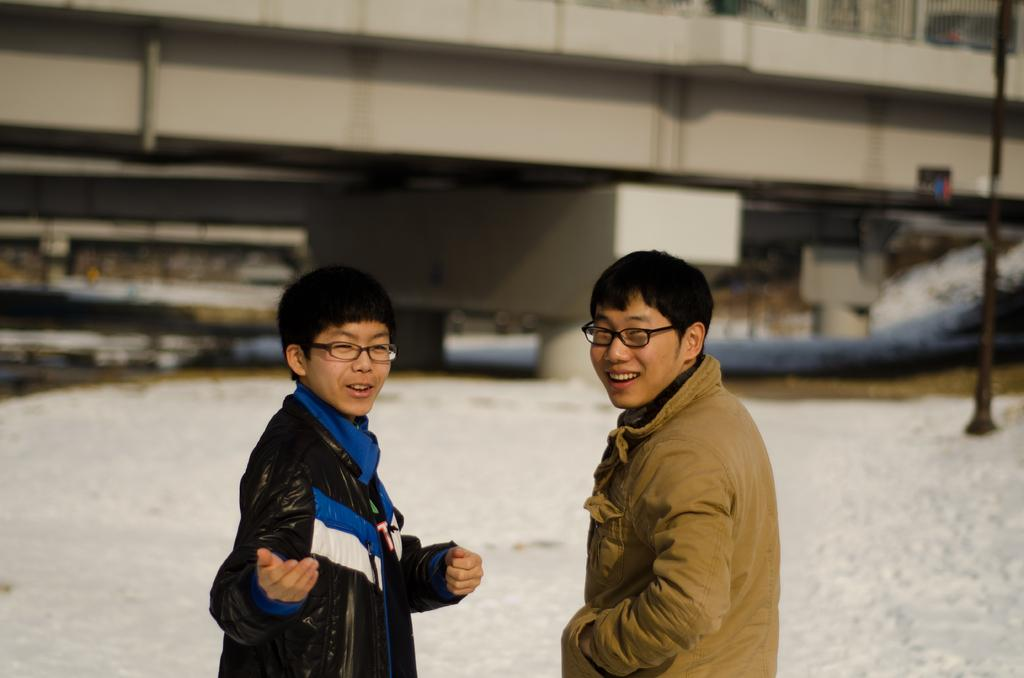How many people are in the image? There are two men in the image. Can you describe the background of the men? The background of the men is blurred. What type of needle is being used by one of the men in the image? There is no needle present in the image. Where is the dock located in the image? There is no dock present in the image. 